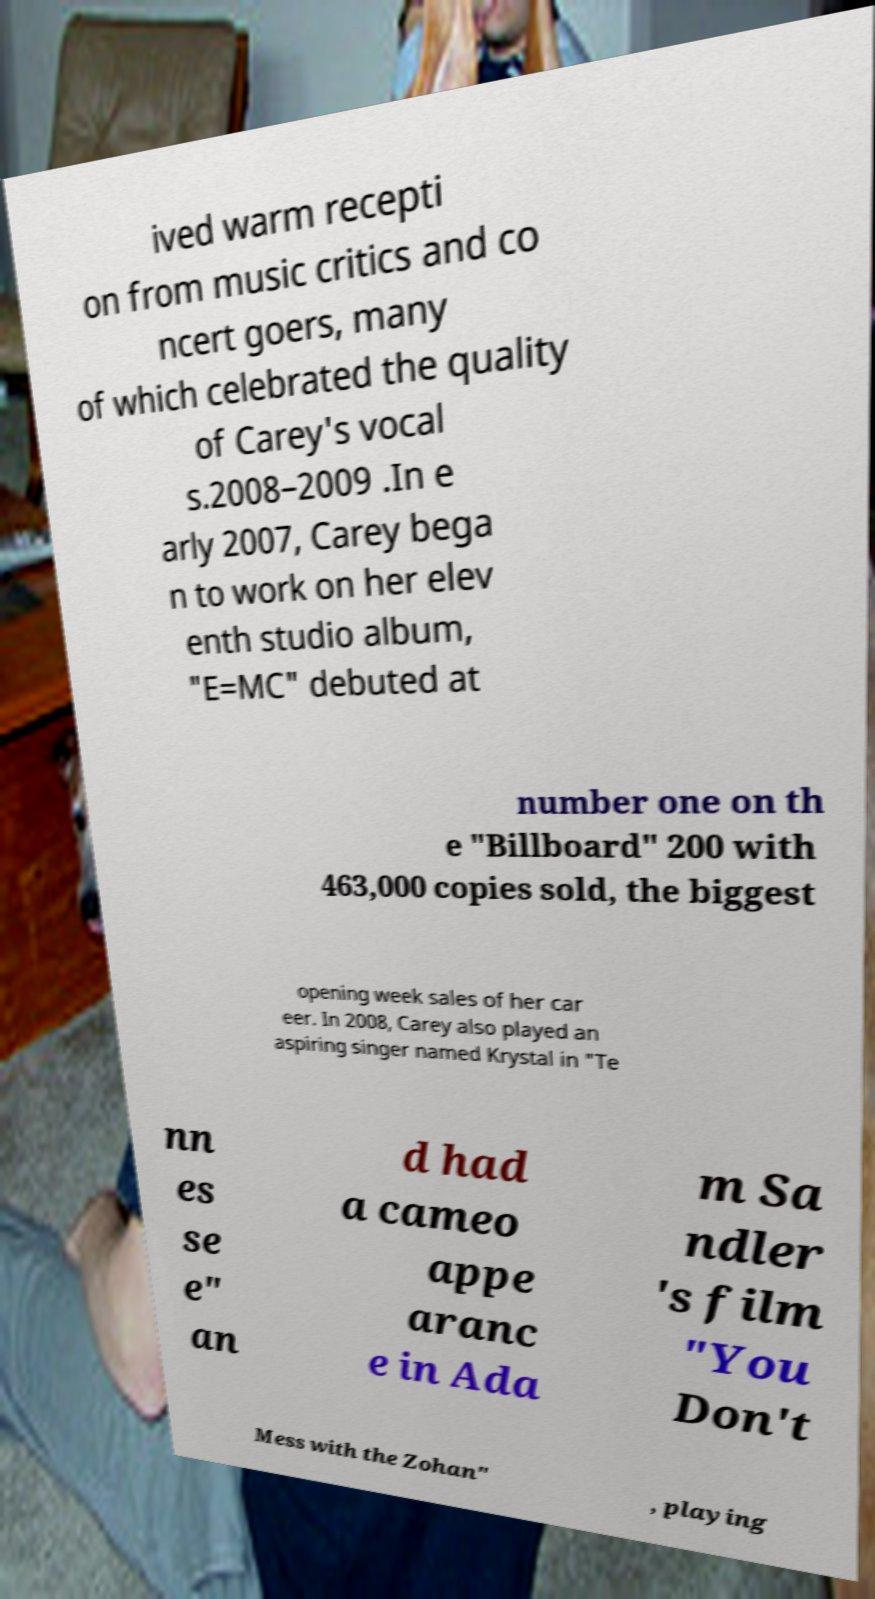Could you assist in decoding the text presented in this image and type it out clearly? ived warm recepti on from music critics and co ncert goers, many of which celebrated the quality of Carey's vocal s.2008–2009 .In e arly 2007, Carey bega n to work on her elev enth studio album, "E=MC" debuted at number one on th e "Billboard" 200 with 463,000 copies sold, the biggest opening week sales of her car eer. In 2008, Carey also played an aspiring singer named Krystal in "Te nn es se e" an d had a cameo appe aranc e in Ada m Sa ndler 's film "You Don't Mess with the Zohan" , playing 